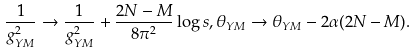Convert formula to latex. <formula><loc_0><loc_0><loc_500><loc_500>\frac { 1 } { g _ { Y M } ^ { 2 } } \rightarrow \frac { 1 } { g _ { Y M } ^ { 2 } } + \frac { 2 N - M } { 8 \pi ^ { 2 } } \log s , \theta _ { Y M } \rightarrow \theta _ { Y M } - 2 \alpha ( 2 N - M ) .</formula> 